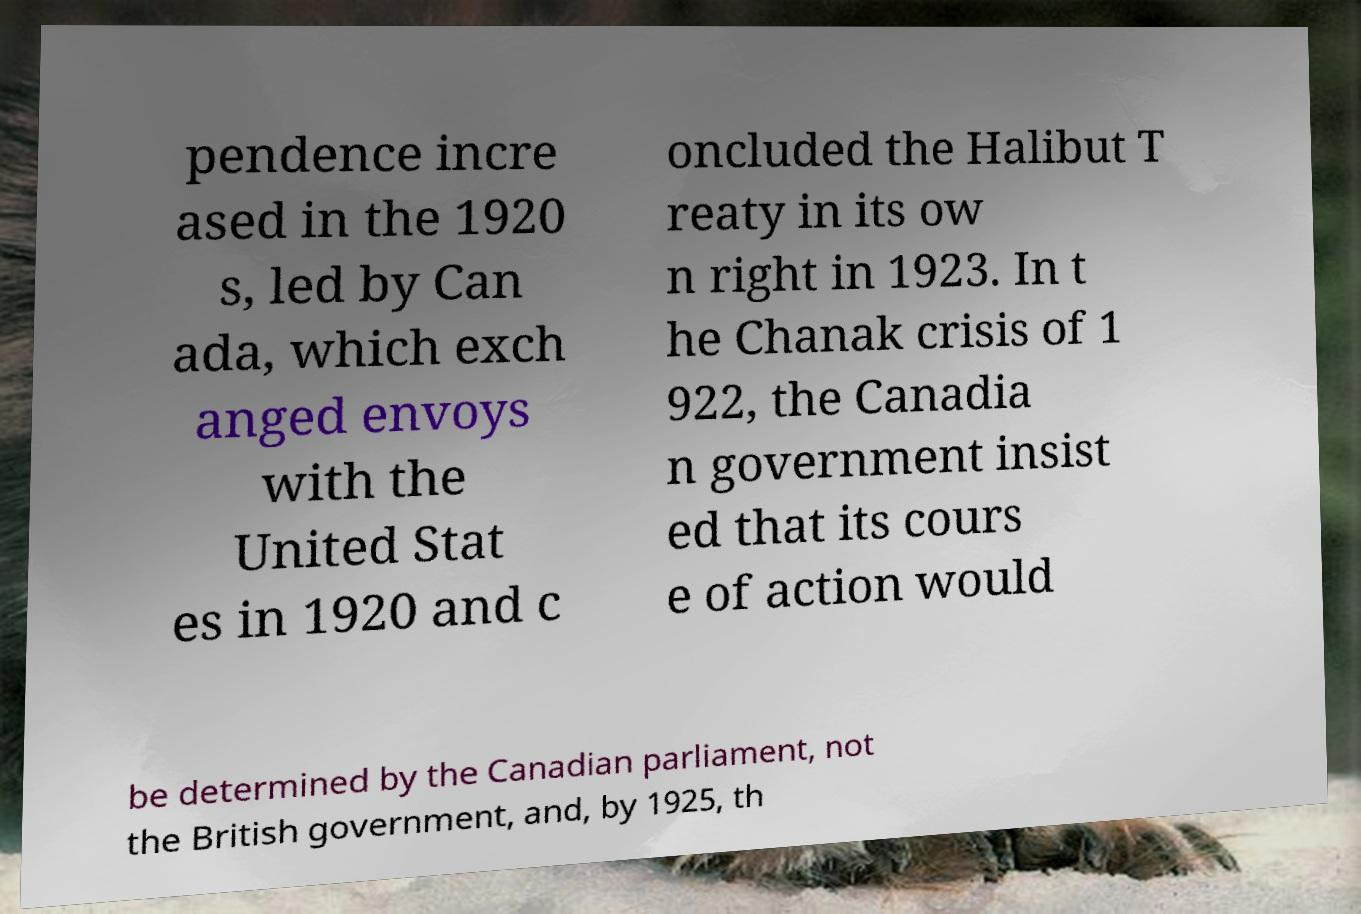I need the written content from this picture converted into text. Can you do that? pendence incre ased in the 1920 s, led by Can ada, which exch anged envoys with the United Stat es in 1920 and c oncluded the Halibut T reaty in its ow n right in 1923. In t he Chanak crisis of 1 922, the Canadia n government insist ed that its cours e of action would be determined by the Canadian parliament, not the British government, and, by 1925, th 